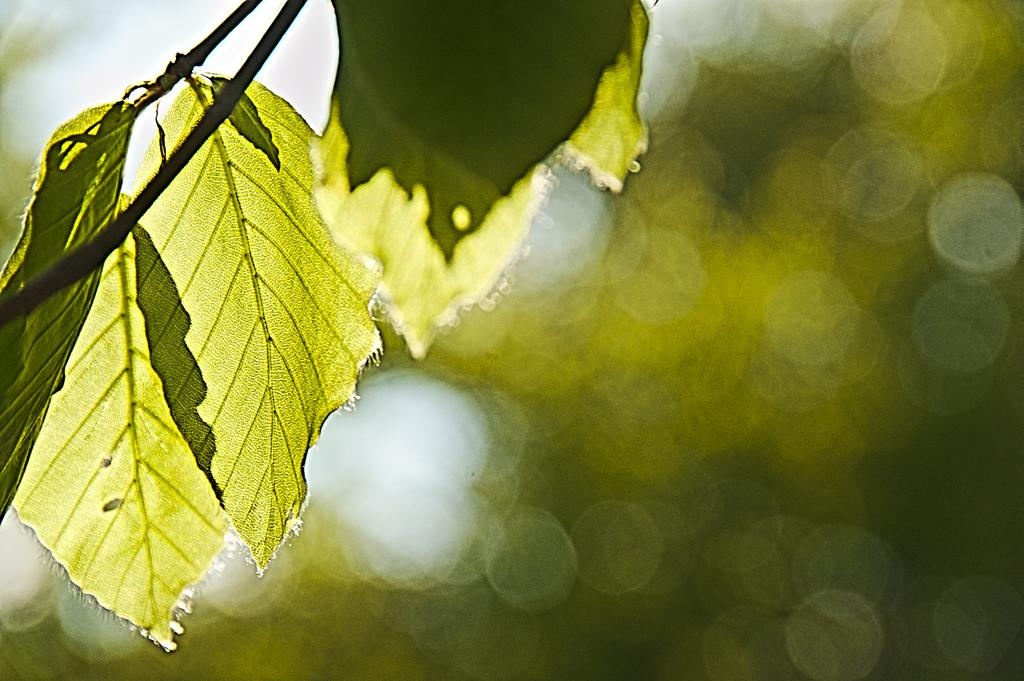What type of natural elements can be seen in the image? There are leaves in the image. Can you describe the color or texture of the leaves? The provided facts do not include information about the color or texture of the leaves. Are the leaves part of a larger plant or tree? The provided facts do not specify whether the leaves are part of a larger plant or tree. What invention is being demonstrated by the ants in the image? There are no ants present in the image, and therefore no invention can be demonstrated by them. 